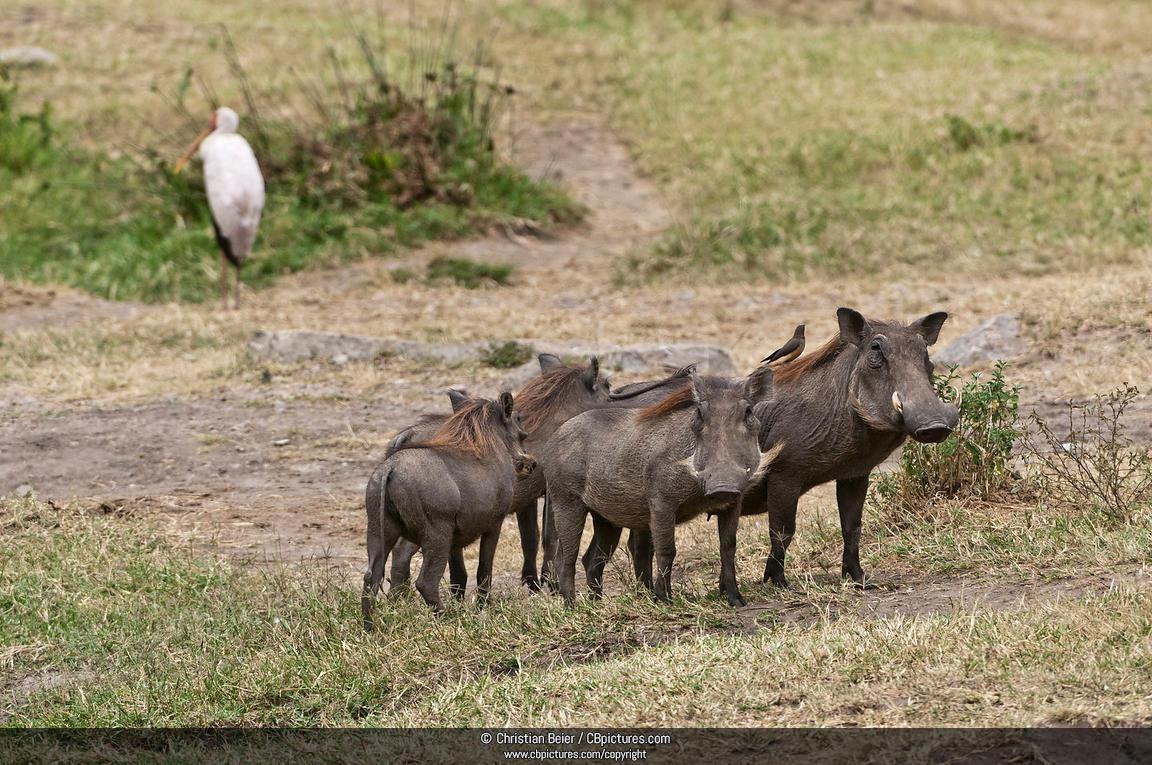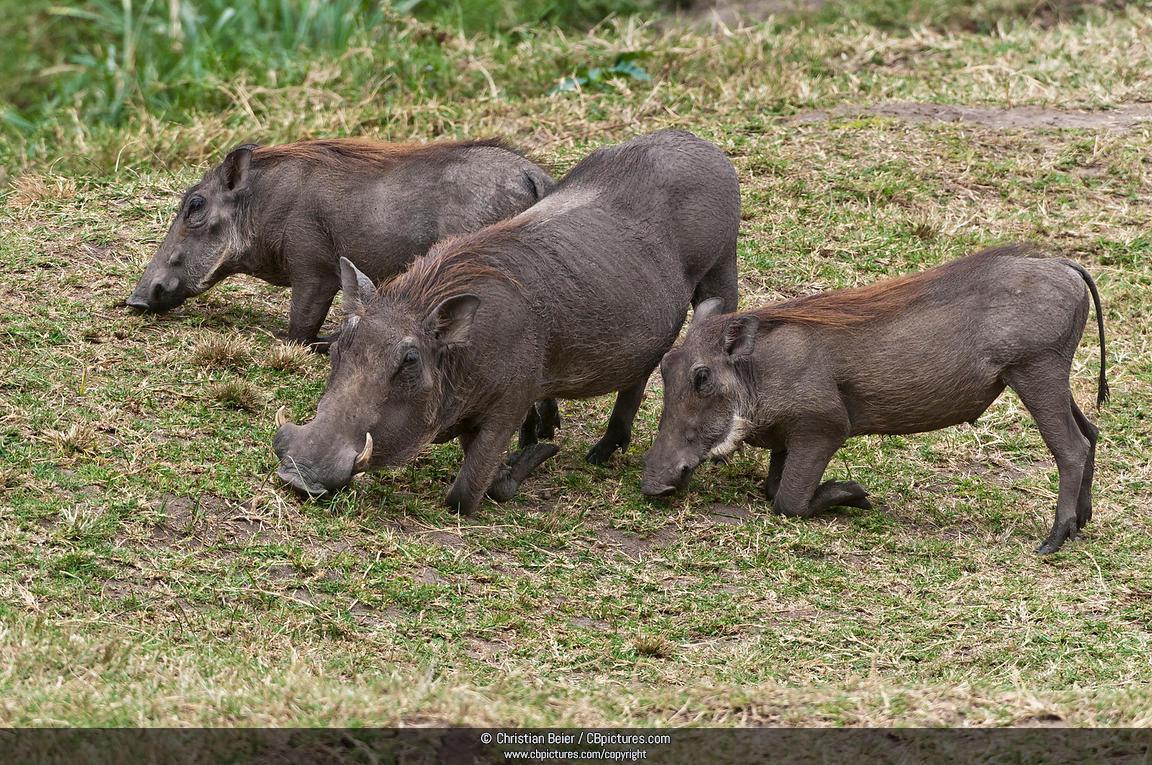The first image is the image on the left, the second image is the image on the right. Examine the images to the left and right. Is the description "In one of the images there is a group of warthogs standing near water." accurate? Answer yes or no. No. The first image is the image on the left, the second image is the image on the right. Analyze the images presented: Is the assertion "There is water in the image on the left." valid? Answer yes or no. No. 